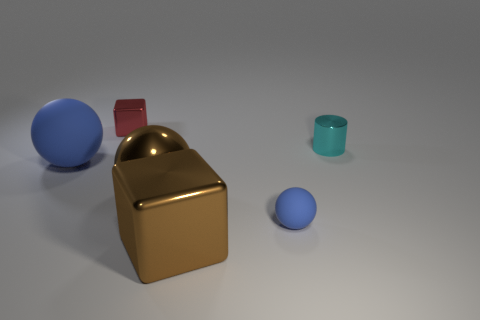Subtract all large brown spheres. How many spheres are left? 2 Subtract all blue blocks. How many blue balls are left? 2 Add 3 tiny cyan metallic cylinders. How many objects exist? 9 Subtract all cylinders. How many objects are left? 5 Subtract 0 gray blocks. How many objects are left? 6 Subtract all purple spheres. Subtract all brown cubes. How many spheres are left? 3 Subtract all brown spheres. Subtract all gray rubber cubes. How many objects are left? 5 Add 4 tiny blue matte things. How many tiny blue matte things are left? 5 Add 3 small blue things. How many small blue things exist? 4 